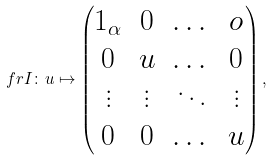<formula> <loc_0><loc_0><loc_500><loc_500>\ f r I \colon u \mapsto \begin{pmatrix} 1 _ { \alpha } & 0 & \dots & o \\ 0 & u & \dots & 0 \\ \vdots & \vdots & \ddots & \vdots \\ 0 & 0 & \dots & u \end{pmatrix} ,</formula> 